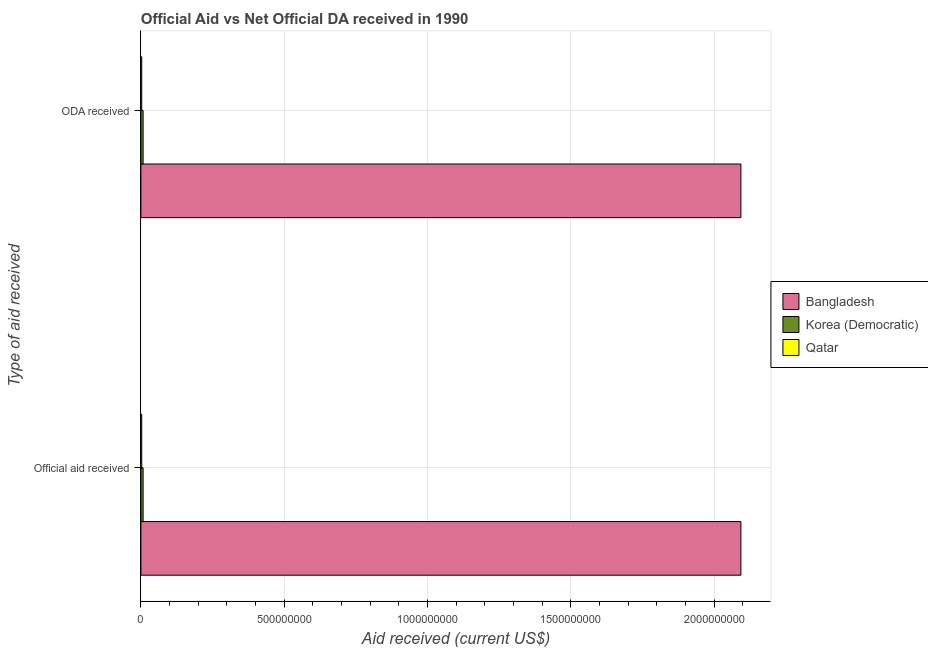How many groups of bars are there?
Provide a succinct answer. 2. How many bars are there on the 2nd tick from the bottom?
Your answer should be compact. 3. What is the label of the 2nd group of bars from the top?
Provide a short and direct response. Official aid received. What is the oda received in Bangladesh?
Offer a terse response. 2.09e+09. Across all countries, what is the maximum official aid received?
Your answer should be very brief. 2.09e+09. Across all countries, what is the minimum oda received?
Offer a very short reply. 2.97e+06. In which country was the official aid received minimum?
Make the answer very short. Qatar. What is the total oda received in the graph?
Ensure brevity in your answer.  2.10e+09. What is the difference between the official aid received in Qatar and that in Bangladesh?
Offer a terse response. -2.09e+09. What is the difference between the official aid received in Korea (Democratic) and the oda received in Qatar?
Keep it short and to the point. 4.76e+06. What is the average official aid received per country?
Ensure brevity in your answer.  7.01e+08. In how many countries, is the official aid received greater than 600000000 US$?
Your answer should be compact. 1. What is the ratio of the oda received in Qatar to that in Bangladesh?
Your answer should be compact. 0. In how many countries, is the official aid received greater than the average official aid received taken over all countries?
Your response must be concise. 1. What does the 1st bar from the top in ODA received represents?
Provide a succinct answer. Qatar. What does the 3rd bar from the bottom in Official aid received represents?
Make the answer very short. Qatar. What is the difference between two consecutive major ticks on the X-axis?
Your response must be concise. 5.00e+08. Where does the legend appear in the graph?
Keep it short and to the point. Center right. How are the legend labels stacked?
Your response must be concise. Vertical. What is the title of the graph?
Your response must be concise. Official Aid vs Net Official DA received in 1990 . Does "Slovenia" appear as one of the legend labels in the graph?
Your answer should be compact. No. What is the label or title of the X-axis?
Keep it short and to the point. Aid received (current US$). What is the label or title of the Y-axis?
Your answer should be very brief. Type of aid received. What is the Aid received (current US$) in Bangladesh in Official aid received?
Provide a short and direct response. 2.09e+09. What is the Aid received (current US$) of Korea (Democratic) in Official aid received?
Your response must be concise. 7.73e+06. What is the Aid received (current US$) in Qatar in Official aid received?
Provide a short and direct response. 2.97e+06. What is the Aid received (current US$) of Bangladesh in ODA received?
Ensure brevity in your answer.  2.09e+09. What is the Aid received (current US$) of Korea (Democratic) in ODA received?
Ensure brevity in your answer.  7.73e+06. What is the Aid received (current US$) of Qatar in ODA received?
Make the answer very short. 2.97e+06. Across all Type of aid received, what is the maximum Aid received (current US$) of Bangladesh?
Ensure brevity in your answer.  2.09e+09. Across all Type of aid received, what is the maximum Aid received (current US$) in Korea (Democratic)?
Offer a terse response. 7.73e+06. Across all Type of aid received, what is the maximum Aid received (current US$) of Qatar?
Provide a short and direct response. 2.97e+06. Across all Type of aid received, what is the minimum Aid received (current US$) in Bangladesh?
Your answer should be very brief. 2.09e+09. Across all Type of aid received, what is the minimum Aid received (current US$) in Korea (Democratic)?
Provide a short and direct response. 7.73e+06. Across all Type of aid received, what is the minimum Aid received (current US$) in Qatar?
Keep it short and to the point. 2.97e+06. What is the total Aid received (current US$) in Bangladesh in the graph?
Give a very brief answer. 4.19e+09. What is the total Aid received (current US$) of Korea (Democratic) in the graph?
Keep it short and to the point. 1.55e+07. What is the total Aid received (current US$) of Qatar in the graph?
Provide a succinct answer. 5.94e+06. What is the difference between the Aid received (current US$) of Bangladesh in Official aid received and that in ODA received?
Make the answer very short. 0. What is the difference between the Aid received (current US$) in Qatar in Official aid received and that in ODA received?
Your response must be concise. 0. What is the difference between the Aid received (current US$) of Bangladesh in Official aid received and the Aid received (current US$) of Korea (Democratic) in ODA received?
Give a very brief answer. 2.09e+09. What is the difference between the Aid received (current US$) in Bangladesh in Official aid received and the Aid received (current US$) in Qatar in ODA received?
Make the answer very short. 2.09e+09. What is the difference between the Aid received (current US$) of Korea (Democratic) in Official aid received and the Aid received (current US$) of Qatar in ODA received?
Keep it short and to the point. 4.76e+06. What is the average Aid received (current US$) in Bangladesh per Type of aid received?
Give a very brief answer. 2.09e+09. What is the average Aid received (current US$) in Korea (Democratic) per Type of aid received?
Your response must be concise. 7.73e+06. What is the average Aid received (current US$) in Qatar per Type of aid received?
Offer a terse response. 2.97e+06. What is the difference between the Aid received (current US$) of Bangladesh and Aid received (current US$) of Korea (Democratic) in Official aid received?
Give a very brief answer. 2.09e+09. What is the difference between the Aid received (current US$) of Bangladesh and Aid received (current US$) of Qatar in Official aid received?
Provide a succinct answer. 2.09e+09. What is the difference between the Aid received (current US$) of Korea (Democratic) and Aid received (current US$) of Qatar in Official aid received?
Provide a short and direct response. 4.76e+06. What is the difference between the Aid received (current US$) of Bangladesh and Aid received (current US$) of Korea (Democratic) in ODA received?
Ensure brevity in your answer.  2.09e+09. What is the difference between the Aid received (current US$) of Bangladesh and Aid received (current US$) of Qatar in ODA received?
Provide a short and direct response. 2.09e+09. What is the difference between the Aid received (current US$) of Korea (Democratic) and Aid received (current US$) of Qatar in ODA received?
Your response must be concise. 4.76e+06. What is the ratio of the Aid received (current US$) of Bangladesh in Official aid received to that in ODA received?
Make the answer very short. 1. What is the difference between the highest and the second highest Aid received (current US$) of Bangladesh?
Keep it short and to the point. 0. What is the difference between the highest and the second highest Aid received (current US$) of Korea (Democratic)?
Provide a short and direct response. 0. What is the difference between the highest and the second highest Aid received (current US$) in Qatar?
Provide a succinct answer. 0. What is the difference between the highest and the lowest Aid received (current US$) in Bangladesh?
Ensure brevity in your answer.  0. 